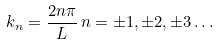<formula> <loc_0><loc_0><loc_500><loc_500>k _ { n } = \frac { 2 n \pi } { L } \, n = \pm 1 , \pm 2 , \pm 3 \dots</formula> 